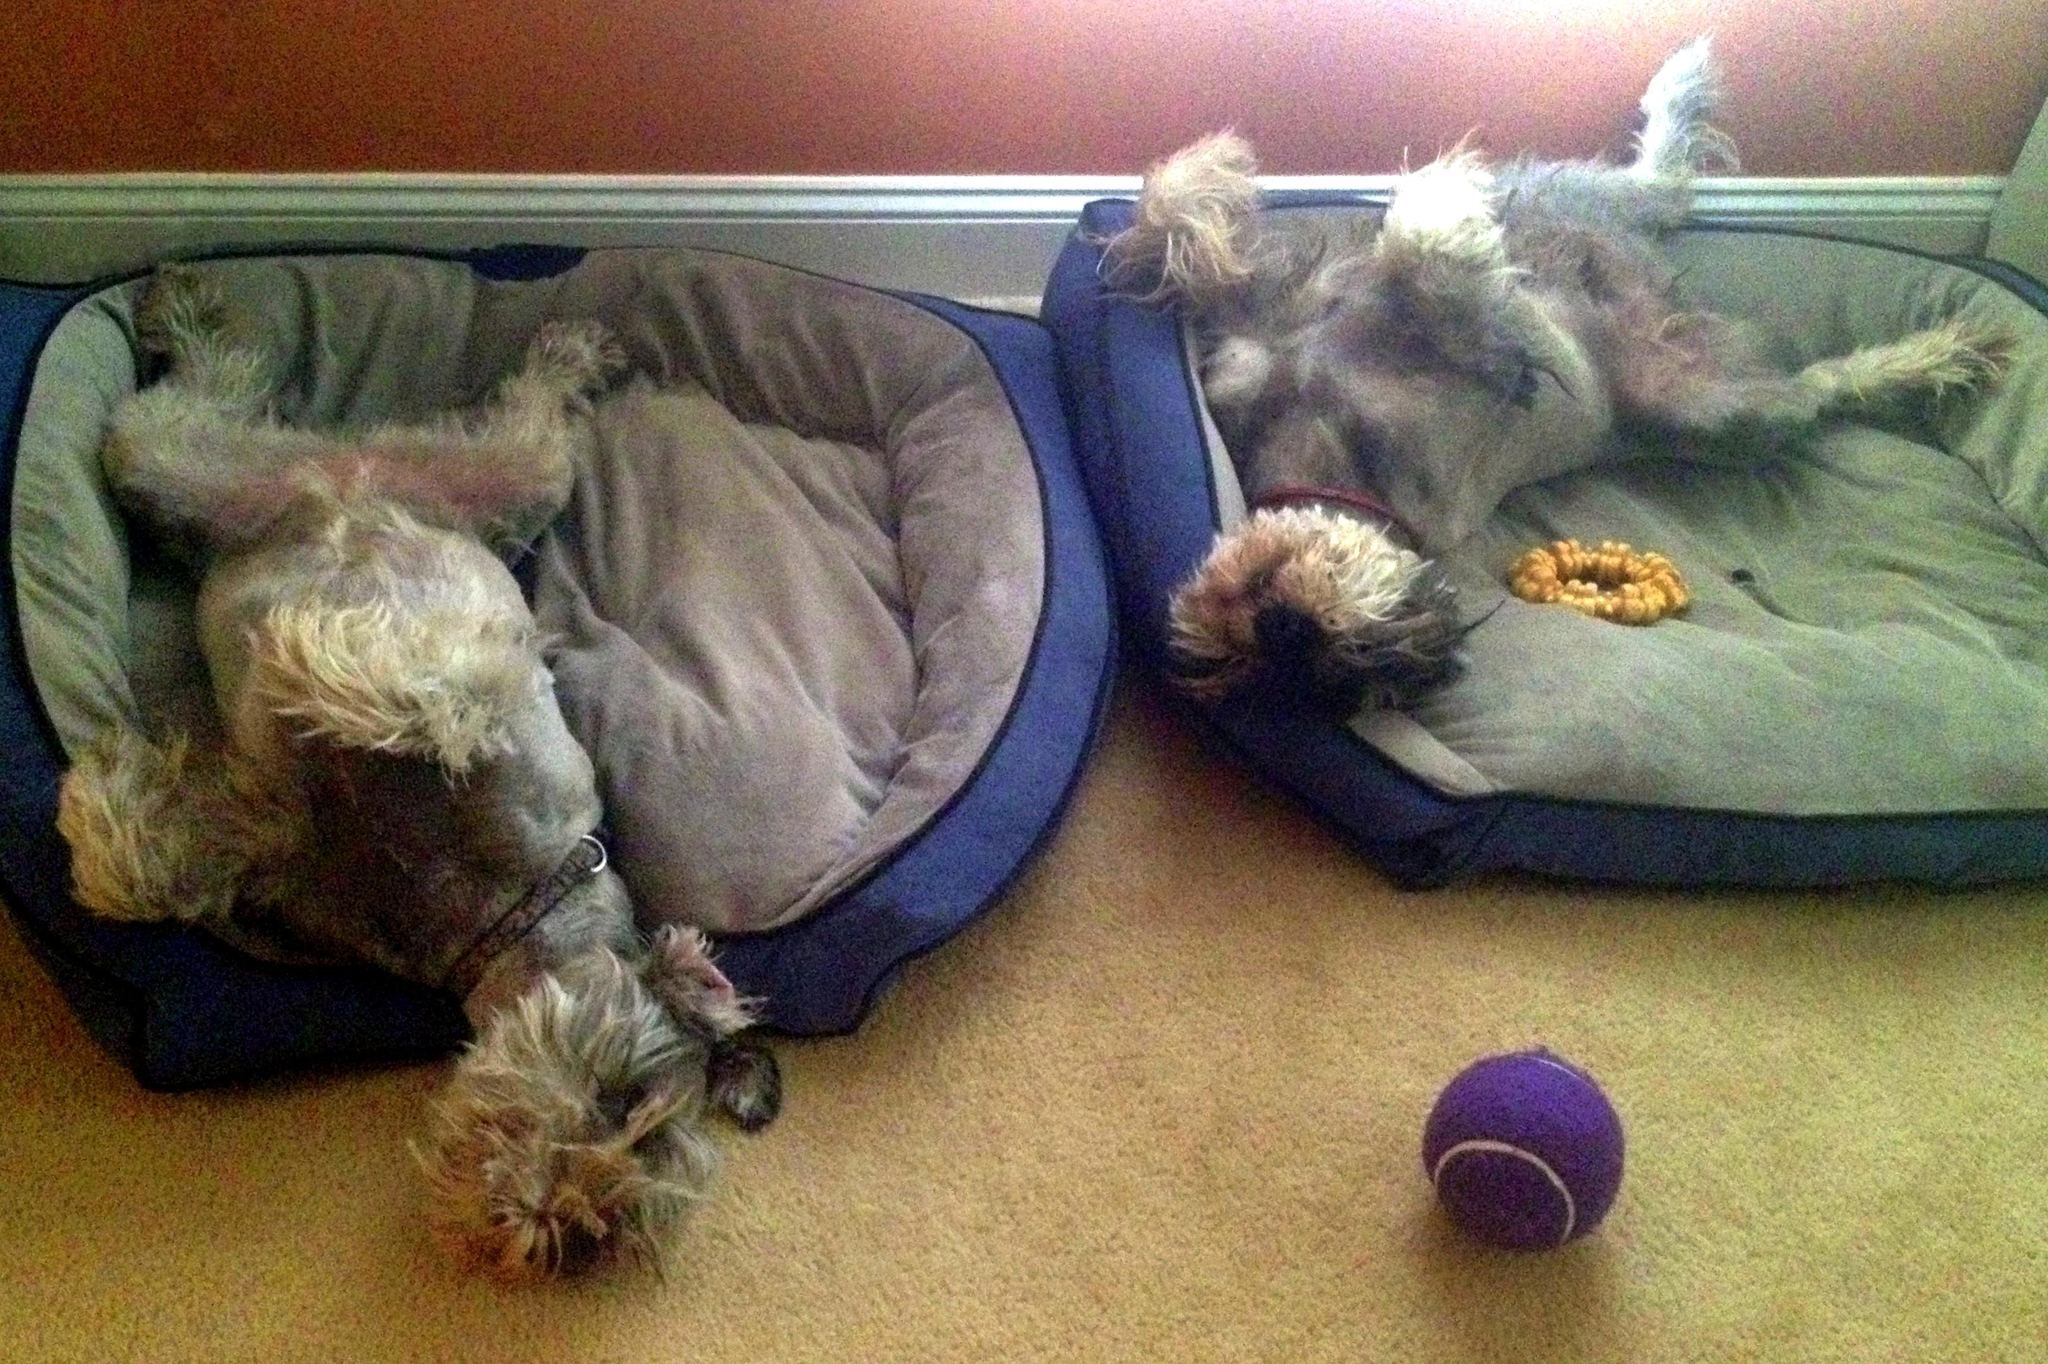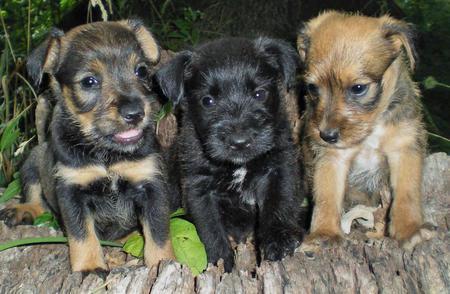The first image is the image on the left, the second image is the image on the right. Given the left and right images, does the statement "There are more dogs in the image on the right." hold true? Answer yes or no. Yes. 